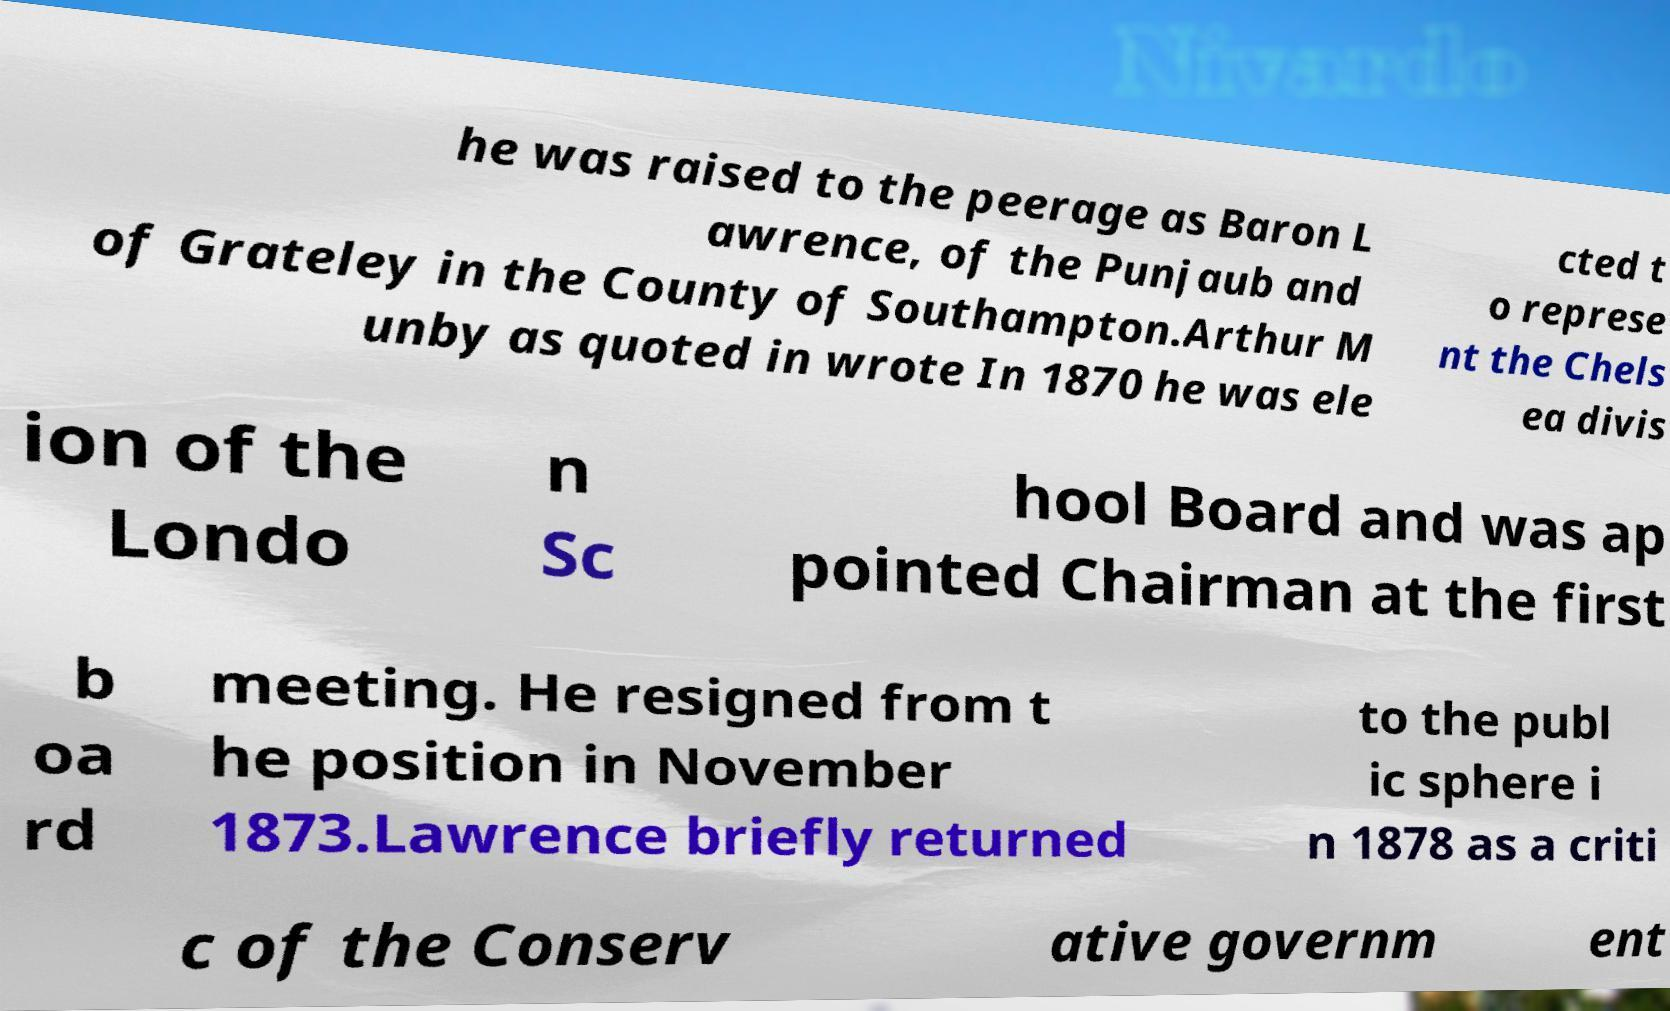What messages or text are displayed in this image? I need them in a readable, typed format. he was raised to the peerage as Baron L awrence, of the Punjaub and of Grateley in the County of Southampton.Arthur M unby as quoted in wrote In 1870 he was ele cted t o represe nt the Chels ea divis ion of the Londo n Sc hool Board and was ap pointed Chairman at the first b oa rd meeting. He resigned from t he position in November 1873.Lawrence briefly returned to the publ ic sphere i n 1878 as a criti c of the Conserv ative governm ent 